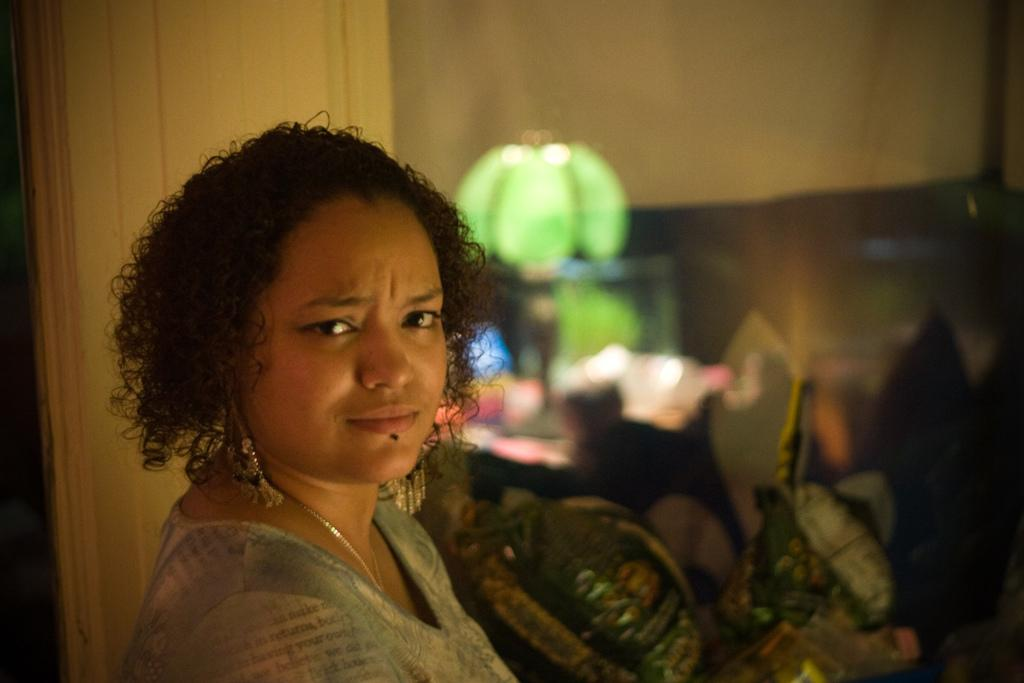Who is the main subject in the image? There is a woman in the middle of the image. What can be seen on the table in the background? There is a green color lamp on a table in the background. What is located behind the woman on the left side of the image? There is a wall behind the woman on the left side of the image. What type of linen is draped over the woman's shoulders in the image? There is no linen draped over the woman's shoulders in the image. How many cups can be seen on the table with the green color lamp? There is no cup visible in the image; only the green color lamp is mentioned on the table. 